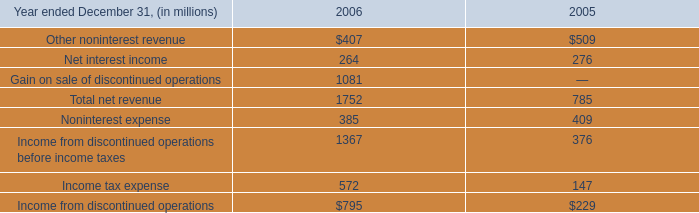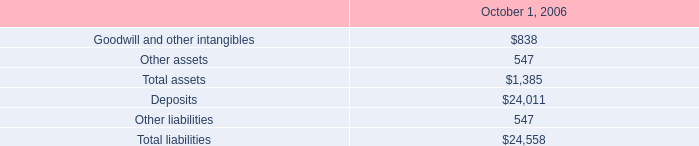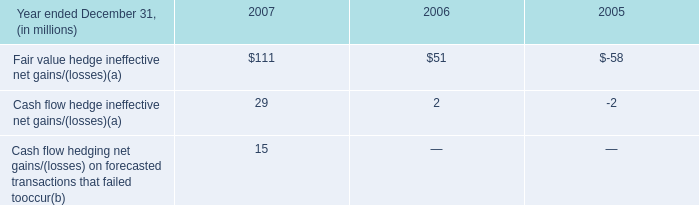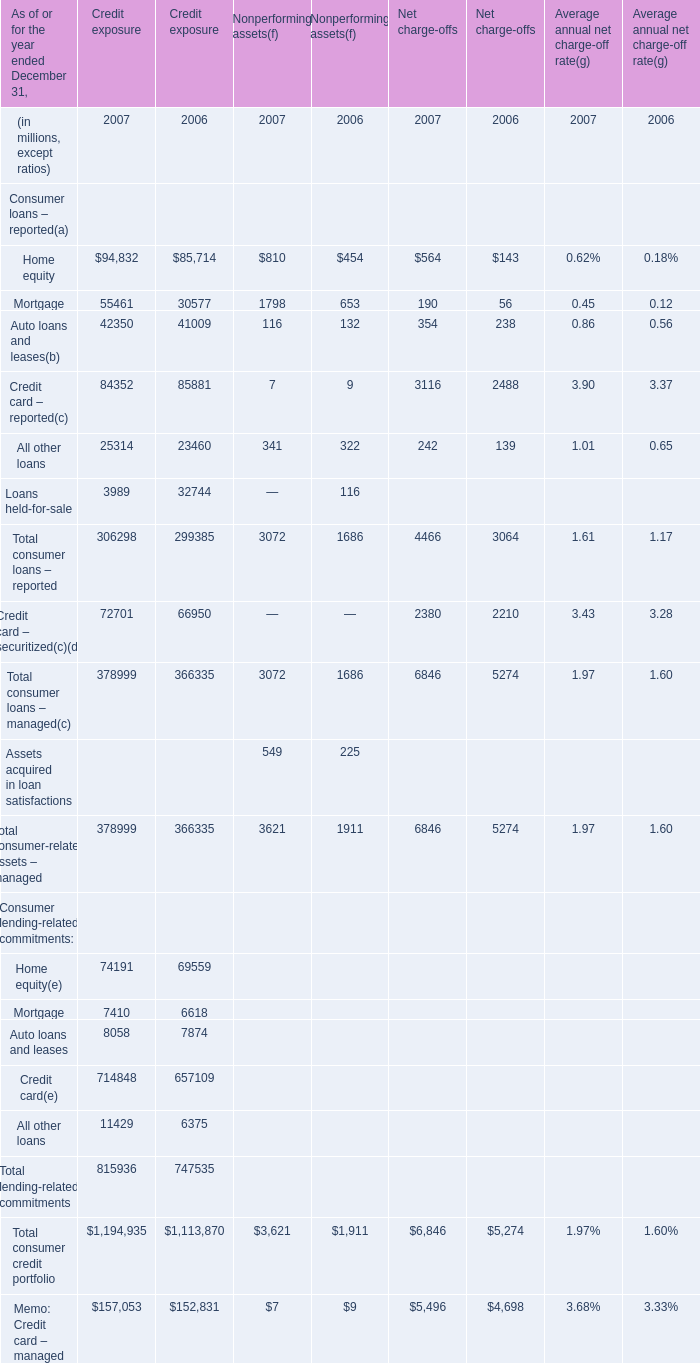What's the growth rate of Mortgage for Nonperforming assets in 2007? (in %) 
Computations: ((1798 - 653) / 653)
Answer: 1.75345. 